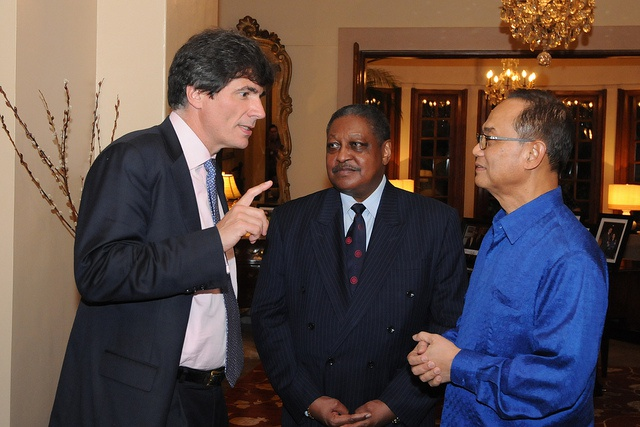Describe the objects in this image and their specific colors. I can see people in tan, black, salmon, and lightgray tones, people in tan, black, maroon, and brown tones, people in tan, blue, navy, darkblue, and black tones, tie in tan, black, and gray tones, and tie in tan, black, maroon, and purple tones in this image. 